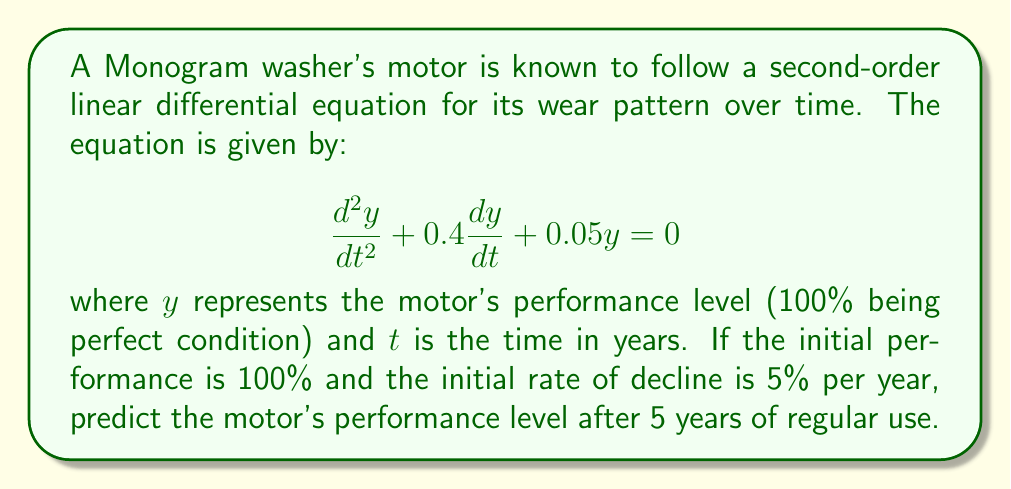Can you answer this question? To solve this problem, we need to follow these steps:

1) The general solution for this second-order linear differential equation is:

   $y = C_1e^{r_1t} + C_2e^{r_2t}$

   where $r_1$ and $r_2$ are the roots of the characteristic equation.

2) The characteristic equation is:
   
   $r^2 + 0.4r + 0.05 = 0$

3) Solving this quadratic equation:
   
   $r = \frac{-0.4 \pm \sqrt{0.4^2 - 4(1)(0.05)}}{2(1)}$
   
   $r = -0.2 \pm \sqrt{0.16 - 0.2} = -0.2 \pm \sqrt{-0.04} = -0.2 \pm 0.2i$

4) Therefore, the general solution is:

   $y = e^{-0.2t}(C_1\cos(0.2t) + C_2\sin(0.2t))$

5) Given initial conditions:
   $y(0) = 100$ (initial performance)
   $y'(0) = -5$ (initial rate of decline)

6) Applying these conditions:
   
   $100 = C_1$
   $-5 = -0.2C_1 + 0.2C_2$

7) Solving these equations:
   
   $C_1 = 100$
   $C_2 = 75$

8) The particular solution is:

   $y = e^{-0.2t}(100\cos(0.2t) + 75\sin(0.2t))$

9) To find the performance after 5 years, we substitute $t = 5$:

   $y(5) = e^{-1}(100\cos(1) + 75\sin(1))$

10) Calculating this value:

    $y(5) \approx 0.368 * (100 * 0.540 + 75 * 0.841) \approx 54.8$

Therefore, after 5 years, the motor's performance level will be approximately 54.8% of its original capacity.
Answer: 54.8% 